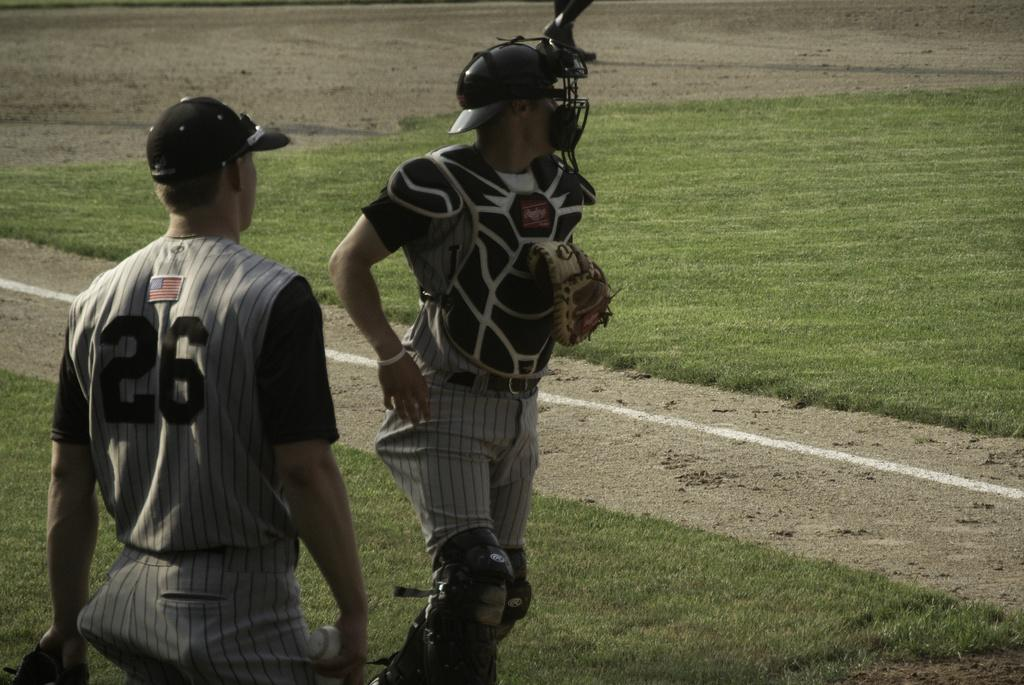How many people are in the image? There are two people in the image. What are the people doing in the image? Both people are on the ground. What are the people wearing on their heads? Both people are wearing black caps. What are the people wearing on their hands? Both people are wearing gloves. What is one person holding in the image? One person is holding a ball. What type of star can be seen in the image? There is no star visible in the image. What kind of building is present in the image? There is no building present in the image. 